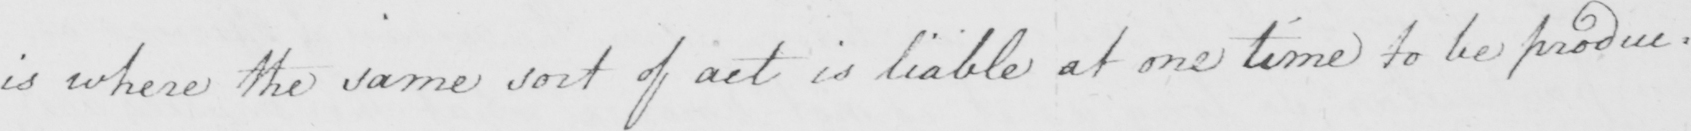Transcribe the text shown in this historical manuscript line. is where the same sort of act is liable at one time to be produc= 